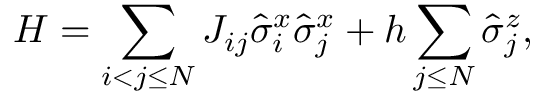<formula> <loc_0><loc_0><loc_500><loc_500>H = \sum _ { i < j \leq N } J _ { i j } \hat { \sigma } _ { i } ^ { x } \hat { \sigma } _ { j } ^ { x } + h \sum _ { j \leq N } \hat { \sigma } _ { j } ^ { z } ,</formula> 